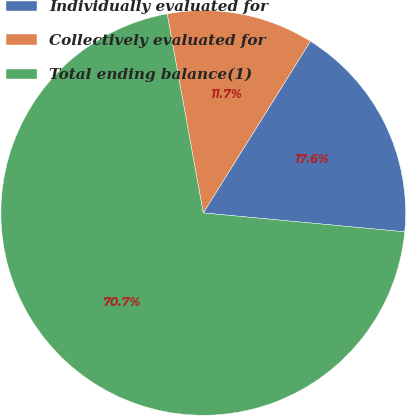Convert chart to OTSL. <chart><loc_0><loc_0><loc_500><loc_500><pie_chart><fcel>Individually evaluated for<fcel>Collectively evaluated for<fcel>Total ending balance(1)<nl><fcel>17.61%<fcel>11.74%<fcel>70.65%<nl></chart> 